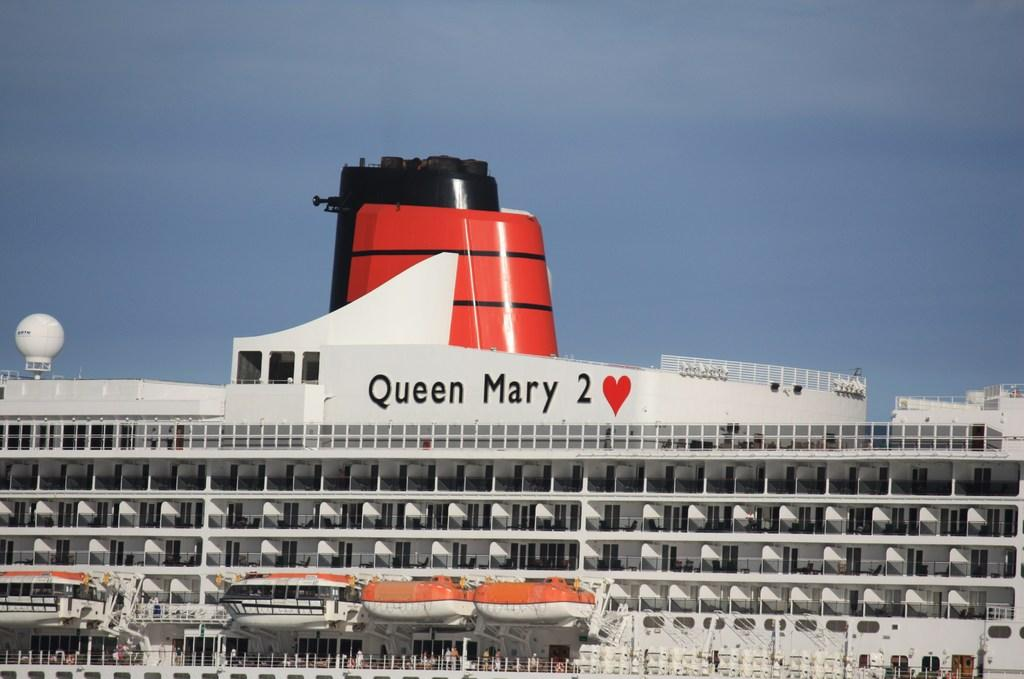What is the main subject of the image? The main subject of the image is a ship. What can be seen in the background of the image? The sky is visible in the image. How many family members are on the ship in the image? There is no information about family members on the ship in the image. What is the size of the appliance on the ship in the image? There is no appliance present on the ship in the image. 